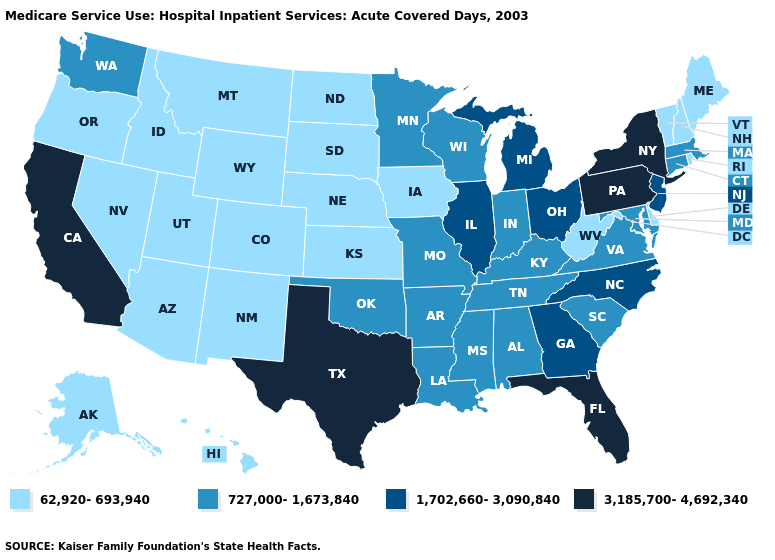Name the states that have a value in the range 727,000-1,673,840?
Concise answer only. Alabama, Arkansas, Connecticut, Indiana, Kentucky, Louisiana, Maryland, Massachusetts, Minnesota, Mississippi, Missouri, Oklahoma, South Carolina, Tennessee, Virginia, Washington, Wisconsin. Name the states that have a value in the range 3,185,700-4,692,340?
Short answer required. California, Florida, New York, Pennsylvania, Texas. What is the highest value in the USA?
Short answer required. 3,185,700-4,692,340. What is the highest value in the USA?
Give a very brief answer. 3,185,700-4,692,340. Which states have the lowest value in the MidWest?
Concise answer only. Iowa, Kansas, Nebraska, North Dakota, South Dakota. What is the lowest value in states that border Nevada?
Concise answer only. 62,920-693,940. Name the states that have a value in the range 62,920-693,940?
Answer briefly. Alaska, Arizona, Colorado, Delaware, Hawaii, Idaho, Iowa, Kansas, Maine, Montana, Nebraska, Nevada, New Hampshire, New Mexico, North Dakota, Oregon, Rhode Island, South Dakota, Utah, Vermont, West Virginia, Wyoming. Does Ohio have the highest value in the MidWest?
Keep it brief. Yes. Does Missouri have the lowest value in the MidWest?
Answer briefly. No. Does Pennsylvania have the highest value in the USA?
Give a very brief answer. Yes. What is the value of Indiana?
Give a very brief answer. 727,000-1,673,840. What is the value of New Hampshire?
Be succinct. 62,920-693,940. Does Massachusetts have the lowest value in the Northeast?
Answer briefly. No. What is the highest value in states that border Maine?
Answer briefly. 62,920-693,940. 